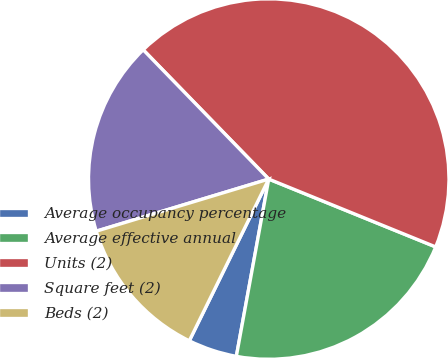Convert chart to OTSL. <chart><loc_0><loc_0><loc_500><loc_500><pie_chart><fcel>Average occupancy percentage<fcel>Average effective annual<fcel>Units (2)<fcel>Square feet (2)<fcel>Beds (2)<nl><fcel>4.39%<fcel>21.73%<fcel>43.41%<fcel>17.4%<fcel>13.06%<nl></chart> 